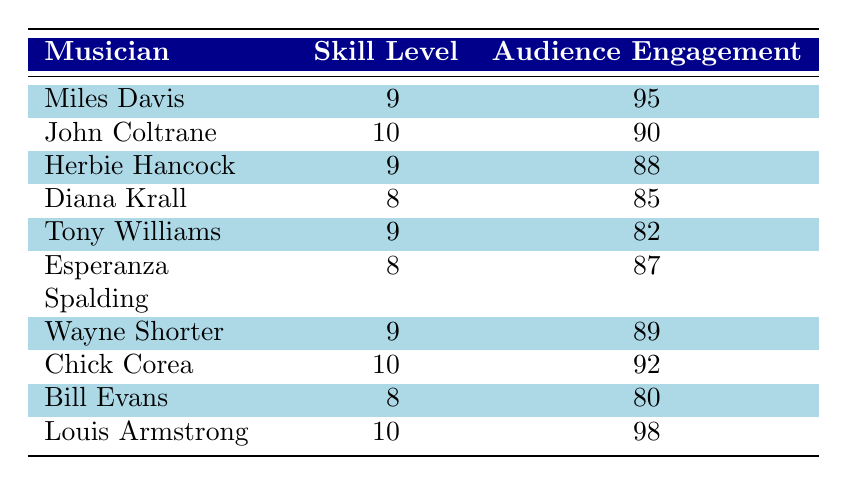What is the audience engagement score of John Coltrane? The table lists John Coltrane under the musician column, with a corresponding audience engagement score of 90.
Answer: 90 Which musician has the highest skill level? The highest skill level listed in the table is 10, which corresponds to John Coltrane, Chick Corea, and Louis Armstrong.
Answer: John Coltrane, Chick Corea, Louis Armstrong What is the average skill level of all the musicians presented? To find the average skill level, sum up the skill levels (9 + 10 + 9 + 8 + 9 + 8 + 9 + 10 + 8 + 10 = 90) and divide by the total number of musicians (10). The average is 90/10 = 9.
Answer: 9 Is there a musician who achieved a score of 98 in audience engagement? Yes, the table indicates that Louis Armstrong has an audience engagement score of 98.
Answer: Yes What is the difference in audience engagement score between the highest and lowest scoring musicians? The highest audience engagement score is 98 (Louis Armstrong) and the lowest is 80 (Bill Evans). The difference is 98 - 80 = 18.
Answer: 18 How many musicians have a skill level of 9 or higher? Looking at the skill levels, Miles Davis, John Coltrane, Herbie Hancock, Tony Williams, Wayne Shorter, Chick Corea, and Louis Armstrong have skill levels of 9 or higher. That totals to 7 musicians.
Answer: 7 Does any musician with a skill level of 8 have an audience engagement score of above 85? Yes, both Diana Krall (85) and Esperanza Spalding (87) have skill levels of 8, but only Esperanza Spalding has a score above 85.
Answer: Yes Which musician’s audience engagement score is closest to the average skill level? The average skill level is 9. The musician with the audience engagement score closest to 90 (the average engagement score) is Chick Corea with a score of 92.
Answer: Chick Corea 